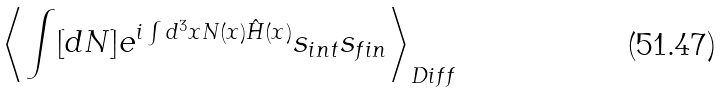Convert formula to latex. <formula><loc_0><loc_0><loc_500><loc_500>\left \langle \int [ d N ] e ^ { i \int d ^ { 3 } x N ( x ) { \hat { H } } ( x ) } s _ { i n t } s _ { f i n } \right \rangle _ { D i f f }</formula> 